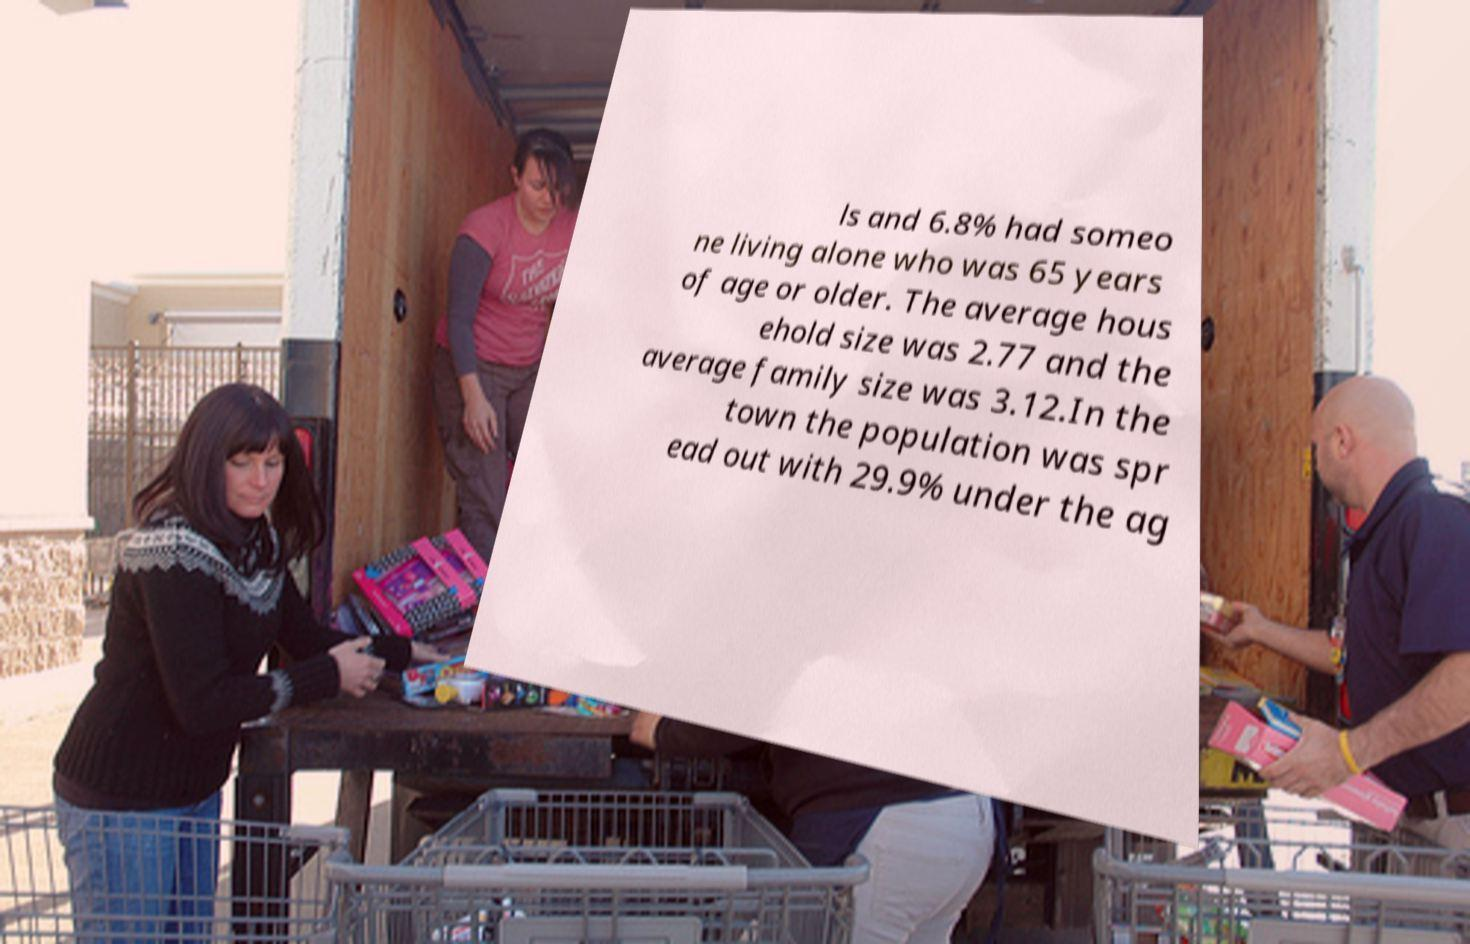What messages or text are displayed in this image? I need them in a readable, typed format. ls and 6.8% had someo ne living alone who was 65 years of age or older. The average hous ehold size was 2.77 and the average family size was 3.12.In the town the population was spr ead out with 29.9% under the ag 